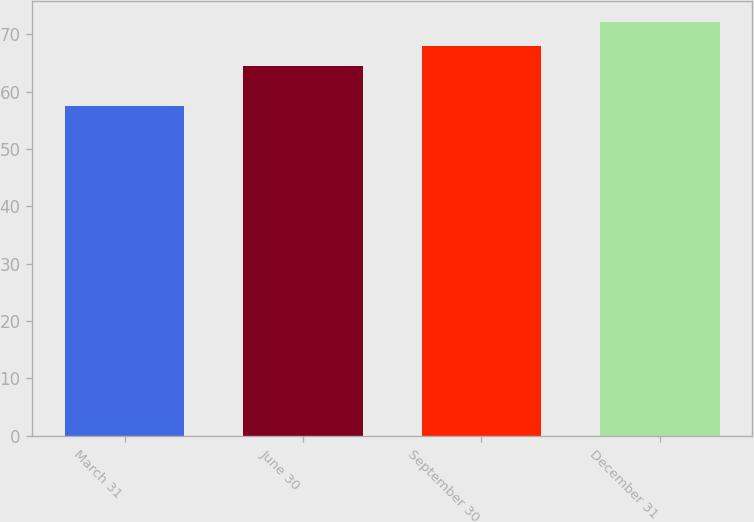Convert chart to OTSL. <chart><loc_0><loc_0><loc_500><loc_500><bar_chart><fcel>March 31<fcel>June 30<fcel>September 30<fcel>December 31<nl><fcel>57.52<fcel>64.48<fcel>67.95<fcel>72.19<nl></chart> 